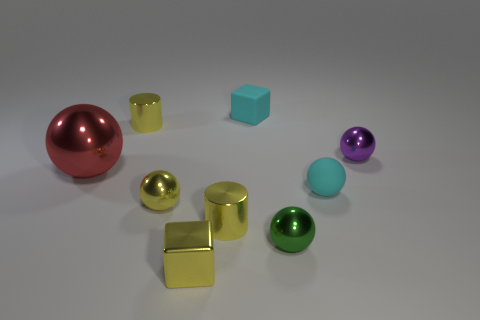Are there any other things that have the same shape as the green metal object?
Offer a terse response. Yes. What is the color of the other matte object that is the same shape as the purple object?
Your answer should be very brief. Cyan. There is a small yellow metal thing that is to the right of the small metallic cube; what is its shape?
Offer a terse response. Cylinder. There is a small shiny cube; are there any tiny shiny objects behind it?
Your answer should be compact. Yes. Is there any other thing that has the same size as the green metal ball?
Your response must be concise. Yes. What color is the block that is made of the same material as the red thing?
Keep it short and to the point. Yellow. Do the tiny matte thing that is to the left of the small matte sphere and the small object that is on the right side of the cyan rubber sphere have the same color?
Your response must be concise. No. How many cylinders are either red metal things or purple objects?
Provide a succinct answer. 0. Are there the same number of large spheres in front of the big metal thing and small purple things?
Make the answer very short. No. What material is the tiny ball that is on the left side of the sphere that is in front of the tiny metal sphere that is left of the tiny cyan block?
Ensure brevity in your answer.  Metal. 